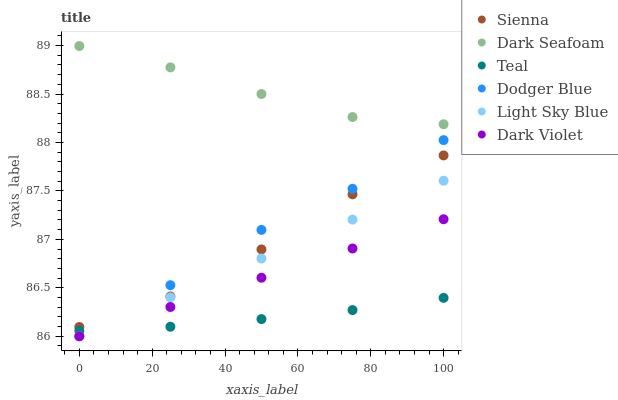Does Teal have the minimum area under the curve?
Answer yes or no. Yes. Does Dark Seafoam have the maximum area under the curve?
Answer yes or no. Yes. Does Sienna have the minimum area under the curve?
Answer yes or no. No. Does Sienna have the maximum area under the curve?
Answer yes or no. No. Is Light Sky Blue the smoothest?
Answer yes or no. Yes. Is Sienna the roughest?
Answer yes or no. Yes. Is Dark Seafoam the smoothest?
Answer yes or no. No. Is Dark Seafoam the roughest?
Answer yes or no. No. Does Dark Violet have the lowest value?
Answer yes or no. Yes. Does Sienna have the lowest value?
Answer yes or no. No. Does Dark Seafoam have the highest value?
Answer yes or no. Yes. Does Sienna have the highest value?
Answer yes or no. No. Is Dark Violet less than Sienna?
Answer yes or no. Yes. Is Sienna greater than Light Sky Blue?
Answer yes or no. Yes. Does Light Sky Blue intersect Teal?
Answer yes or no. Yes. Is Light Sky Blue less than Teal?
Answer yes or no. No. Is Light Sky Blue greater than Teal?
Answer yes or no. No. Does Dark Violet intersect Sienna?
Answer yes or no. No. 